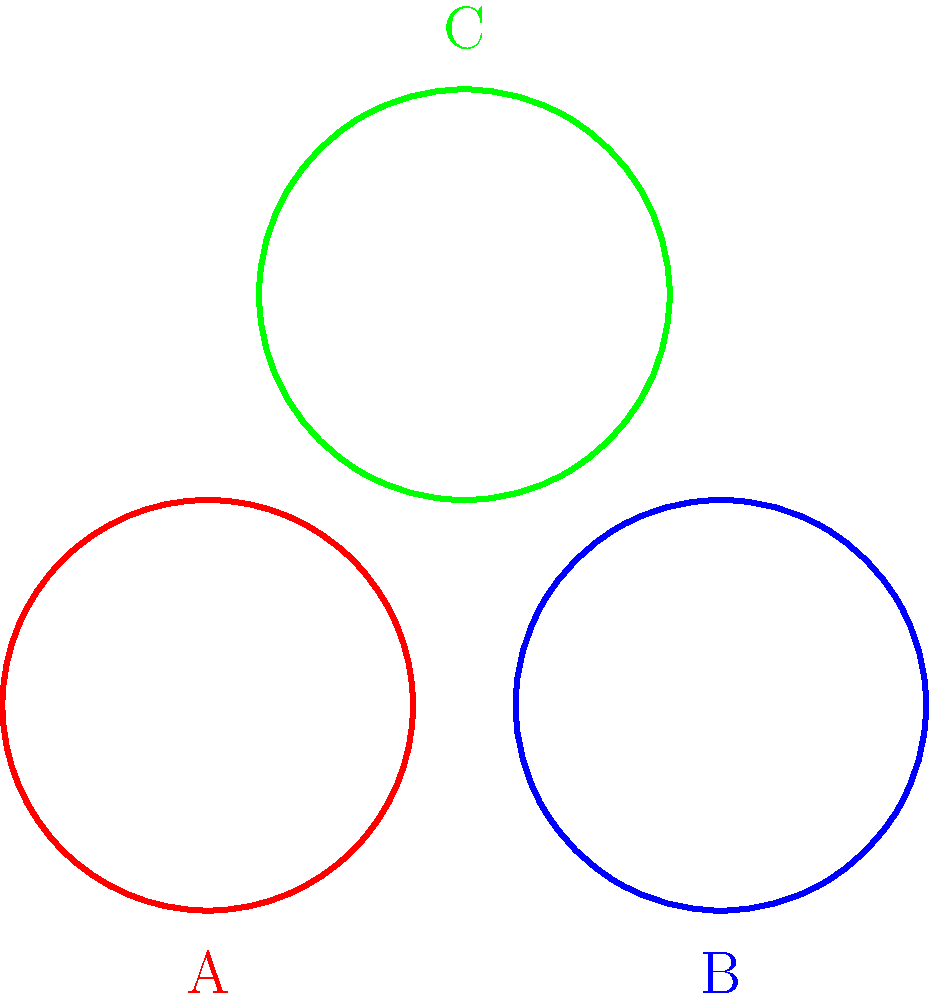Which of the wood carving techniques represented in the image is most commonly associated with Polynesian cultures, particularly in Maori art? To answer this question, let's analyze the characteristics of each carving technique shown in the image:

1. Technique A (red): This shows a circular pattern with 8 divisions, creating a star-like shape. This is reminiscent of geometric patterns found in various cultures but is not typically associated with Polynesian art.

2. Technique B (blue): This circular pattern has 12 divisions, creating a more intricate, flower-like design. While beautiful, this is not characteristic of traditional Polynesian carving.

3. Technique C (green): This pattern shows 6 divisions in a circular form, creating a spiral-like effect. This technique closely resembles the koru pattern, which is a fundamental element in Maori art and broader Polynesian culture.

The koru, meaning "loop" or "coil" in Maori, is a spiral shape based on the unfurling silver fern frond. It symbolizes new life, growth, strength, and peace in Maori culture. This motif is extensively used in Maori wood carving, tattoos (ta moko), and other art forms.

The simplified, bold curves of Technique C most closely align with the koru pattern, making it the most likely to be associated with Polynesian, particularly Maori, wood carving techniques.
Answer: Technique C (green) 